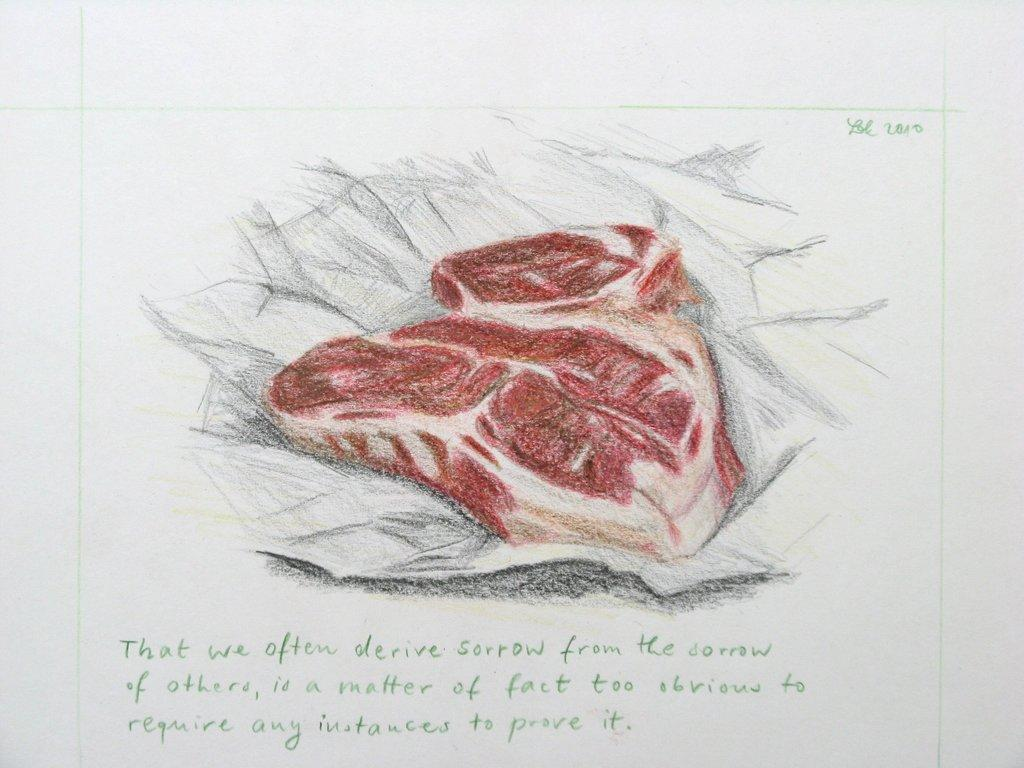What is the medium of the image? The image appears to be a drawing. Is there any text associated with the drawing? Yes, there is text written under the drawing. What object can be seen in the drawing? There is an object that resembles a piece of meat in the image. How many cows are visible in the image? There are no cows present in the image. What type of power is being generated by the object in the image? The image does not depict any power-generating objects. 